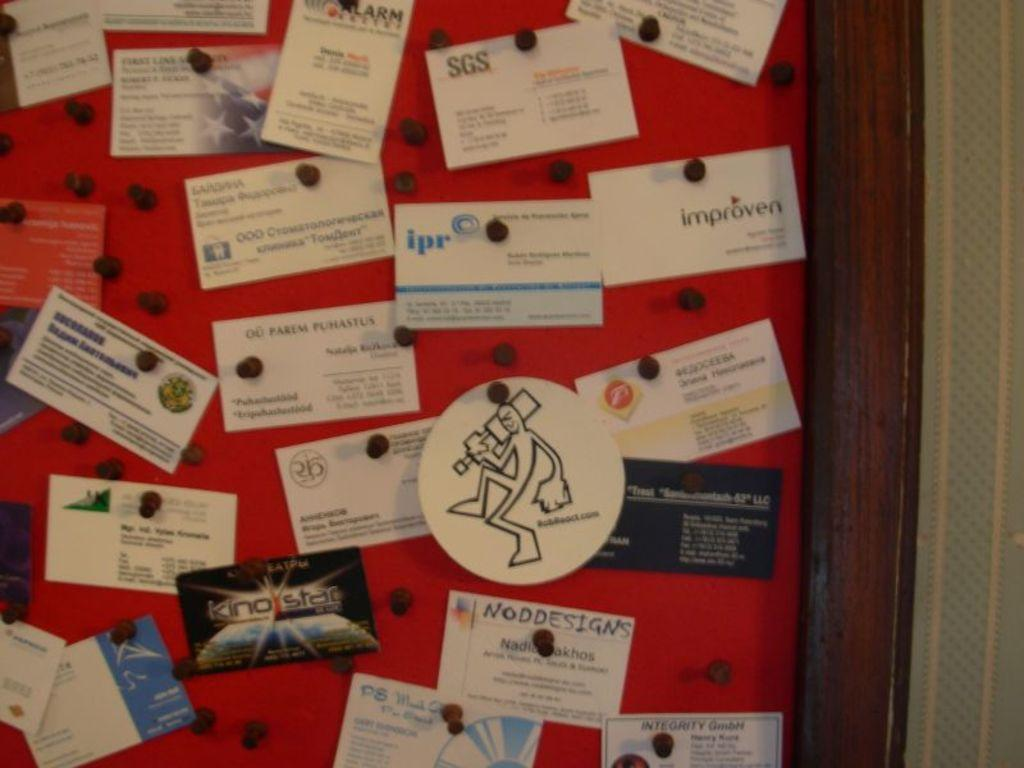<image>
Offer a succinct explanation of the picture presented. a note card with the letters ipr on it 